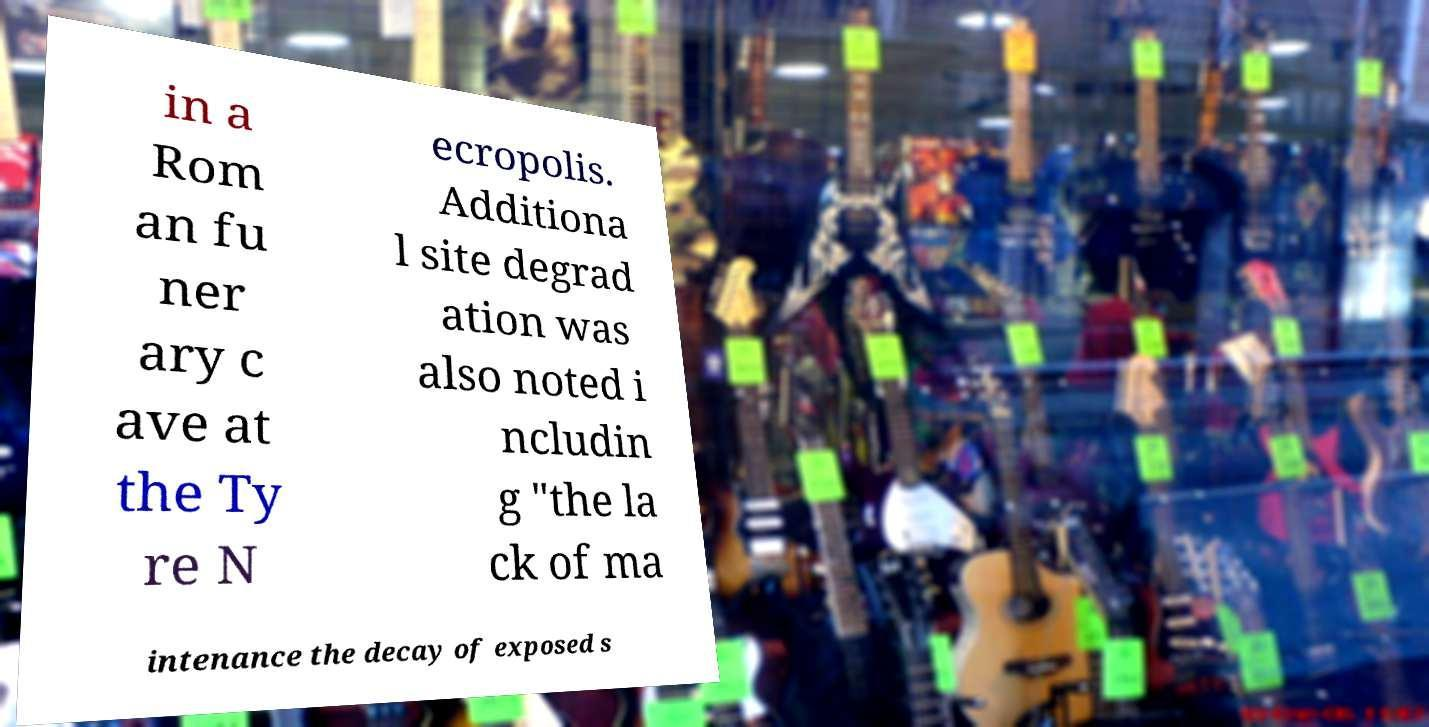Can you accurately transcribe the text from the provided image for me? in a Rom an fu ner ary c ave at the Ty re N ecropolis. Additiona l site degrad ation was also noted i ncludin g "the la ck of ma intenance the decay of exposed s 